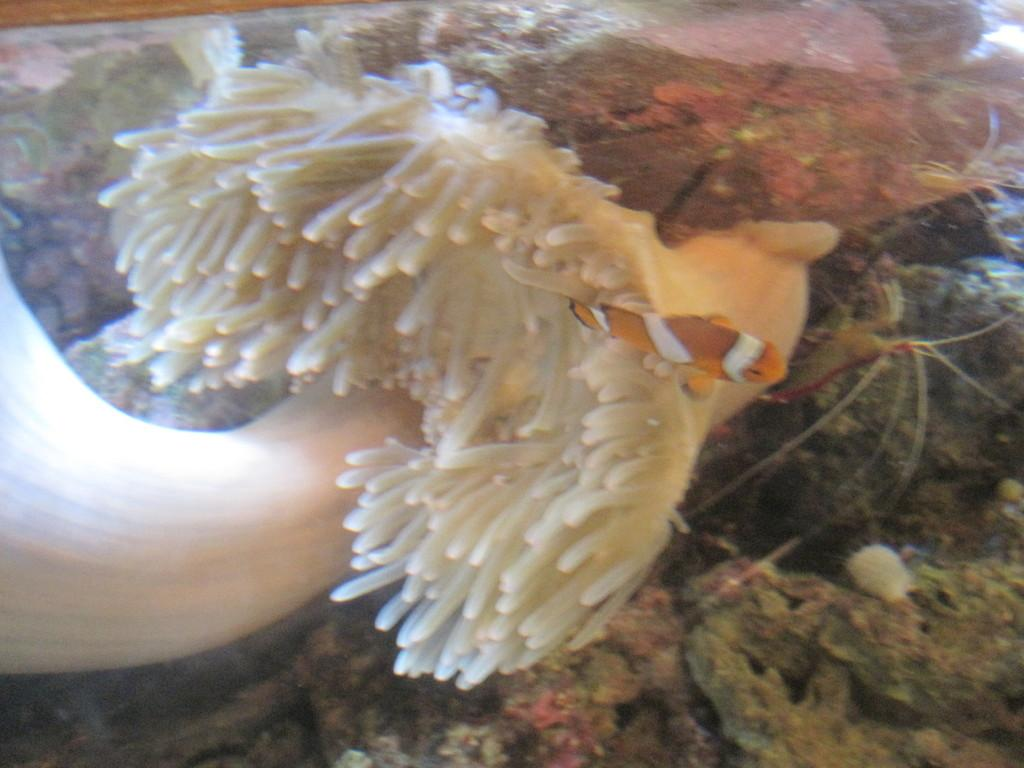What type of plant is in the image? There is a marine plant in the image. What animals are present in the image? There are frogs in the image. What other living creature can be seen in the image? There is a fish in the water in the image. What type of chin can be seen on the frogs in the image? There are no visible chins on the frogs in the image. How many pets are present in the image? There are no pets mentioned or depicted in the image. 